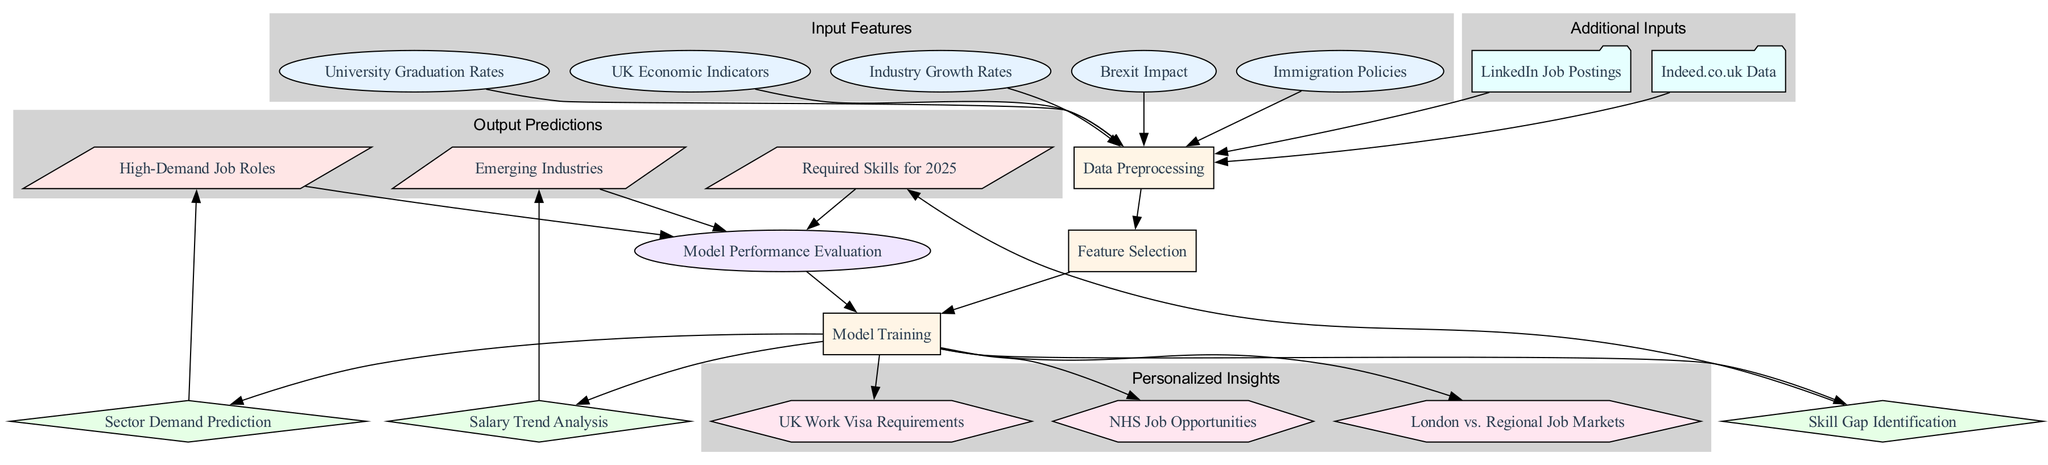What are the input features in the diagram? The input features are listed under the "Input Features" section of the diagram. They include: UK Economic Indicators, Industry Growth Rates, Brexit Impact, Immigration Policies, and University Graduation Rates.
Answer: UK Economic Indicators, Industry Growth Rates, Brexit Impact, Immigration Policies, University Graduation Rates How many processing nodes are there? By counting the nodes labeled as processing nodes in the diagram, there are three: Data Preprocessing, Feature Selection, and Model Training.
Answer: Three What is the output of the "Sector Demand Prediction" node? The "Sector Demand Prediction" node leads to the output prediction labeled as "High-Demand Job Roles." Therefore, its output is related to identifying job roles that have high demand in the market.
Answer: High-Demand Job Roles What do the additional inputs contribute to? The additional inputs, which are LinkedIn Job Postings and Indeed.co.uk Data, contribute to the Data Preprocessing node, enhancing the model's input dataset for analysis.
Answer: Data Preprocessing Which node connects directly to the feedback loop? The feedback loop is connected directly to three output predictions: High-Demand Job Roles, Emerging Industries, and Required Skills for 2025, indicating they all feed back into model performance evaluation.
Answer: High-Demand Job Roles, Emerging Industries, Required Skills for 2025 How many decision nodes are there in the model? The decision nodes consist of Sector Demand Prediction, Salary Trend Analysis, and Skill Gap Identification, totaling three decision nodes in the model.
Answer: Three What type of node is "Model Training"? The "Model Training" is categorized as a processing node, as indicated by its placement and styling within the diagram reflecting its function in training the machine learning model.
Answer: Processing node What insights are personalized in the model? The personalized insights, which offer tailored information based on individual circumstances, include UK Work Visa Requirements, NHS Job Opportunities, and London vs. Regional Job Markets.
Answer: UK Work Visa Requirements, NHS Job Opportunities, London vs. Regional Job Markets What is the relationship between the "Feature Selection" and "Model Training" nodes? The "Feature Selection" node leads directly into the "Model Training" node, indicating that the selected features are key inputs for training the machine learning model.
Answer: Feature Selection leads to Model Training 